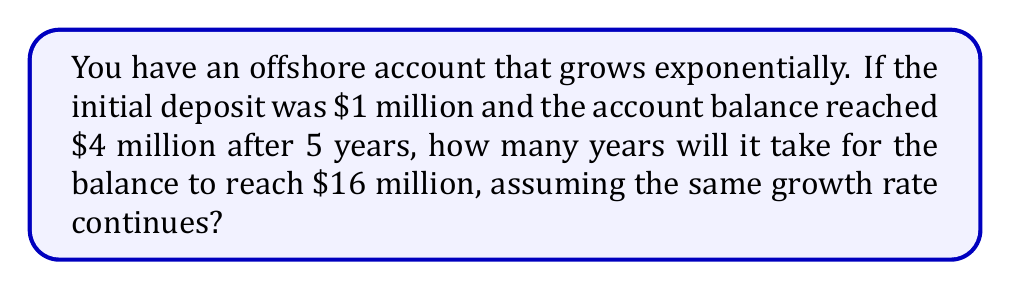Can you solve this math problem? Let's approach this step-by-step using logarithmic functions:

1) Let $A(t)$ be the amount in the account after $t$ years. We know that:
   $A(0) = 1,000,000$ (initial deposit)
   $A(5) = 4,000,000$ (after 5 years)

2) The exponential growth function is of the form:
   $A(t) = A_0 \cdot b^t$
   where $A_0$ is the initial amount and $b$ is the growth factor.

3) We can find $b$ using the given information:
   $4,000,000 = 1,000,000 \cdot b^5$
   $4 = b^5$
   $b = \sqrt[5]{4} = 4^{\frac{1}{5}}$

4) Now, we want to find $t$ when $A(t) = 16,000,000$:
   $16,000,000 = 1,000,000 \cdot (4^{\frac{1}{5}})^t$

5) Simplify:
   $16 = (4^{\frac{1}{5}})^t$

6) Take the logarithm of both sides:
   $\log 16 = t \cdot \log(4^{\frac{1}{5}})$

7) Simplify using logarithm properties:
   $4 = t \cdot \frac{1}{5} \log 4$

8) Solve for $t$:
   $t = \frac{4}{\frac{1}{5} \log 4} = 20 \cdot \frac{\log 4}{\log 4} = 20$

Therefore, it will take 20 years for the account to reach $16 million.
Answer: 20 years 